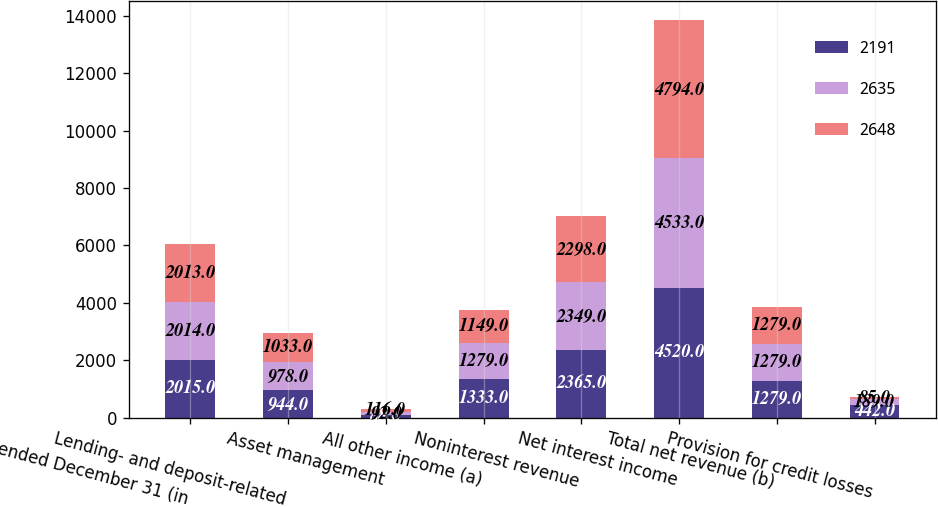Convert chart to OTSL. <chart><loc_0><loc_0><loc_500><loc_500><stacked_bar_chart><ecel><fcel>Year ended December 31 (in<fcel>Lending- and deposit-related<fcel>Asset management<fcel>All other income (a)<fcel>Noninterest revenue<fcel>Net interest income<fcel>Total net revenue (b)<fcel>Provision for credit losses<nl><fcel>2191<fcel>2015<fcel>944<fcel>88<fcel>1333<fcel>2365<fcel>4520<fcel>1279<fcel>442<nl><fcel>2635<fcel>2014<fcel>978<fcel>92<fcel>1279<fcel>2349<fcel>4533<fcel>1279<fcel>189<nl><fcel>2648<fcel>2013<fcel>1033<fcel>116<fcel>1149<fcel>2298<fcel>4794<fcel>1279<fcel>85<nl></chart> 